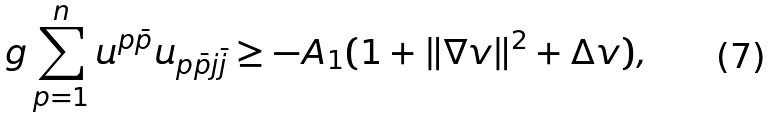<formula> <loc_0><loc_0><loc_500><loc_500>g \sum _ { p = 1 } ^ { n } u ^ { p \bar { p } } u _ { p \bar { p } j \bar { j } } \geq - A _ { 1 } ( 1 + \| \nabla v \| ^ { 2 } + \Delta v ) ,</formula> 